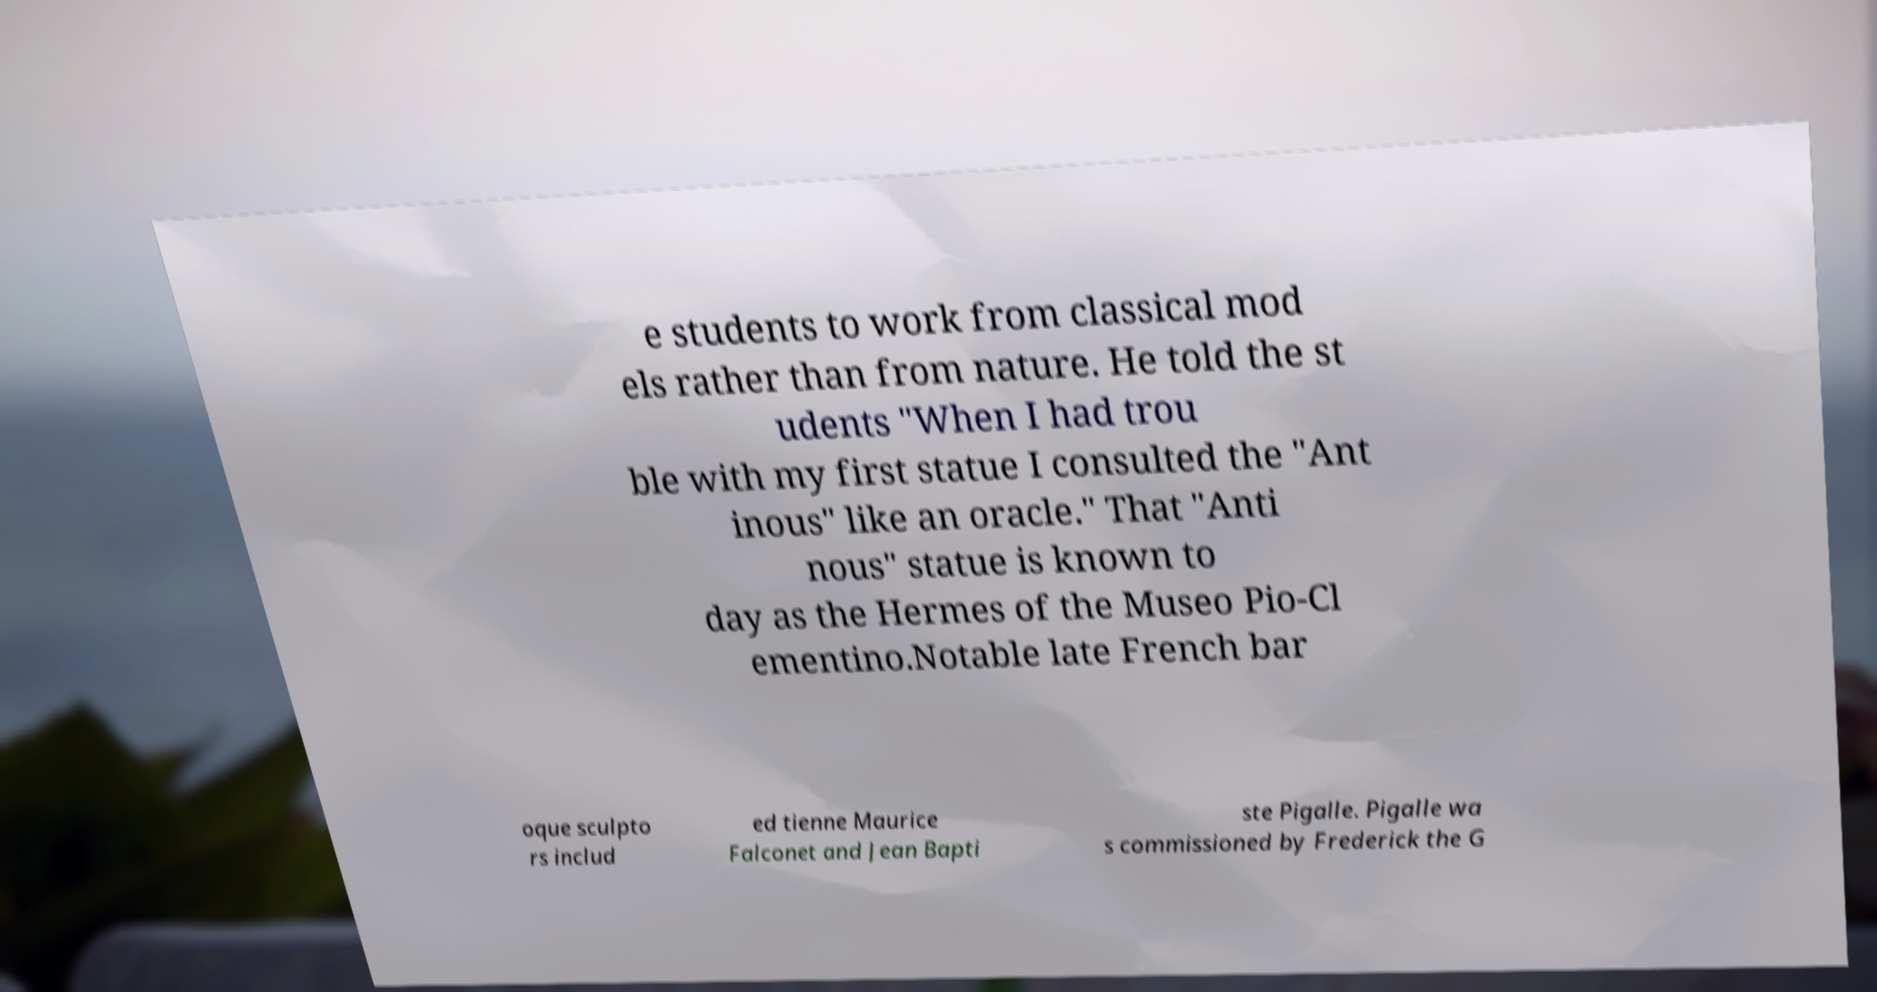Could you extract and type out the text from this image? e students to work from classical mod els rather than from nature. He told the st udents "When I had trou ble with my first statue I consulted the "Ant inous" like an oracle." That "Anti nous" statue is known to day as the Hermes of the Museo Pio-Cl ementino.Notable late French bar oque sculpto rs includ ed tienne Maurice Falconet and Jean Bapti ste Pigalle. Pigalle wa s commissioned by Frederick the G 